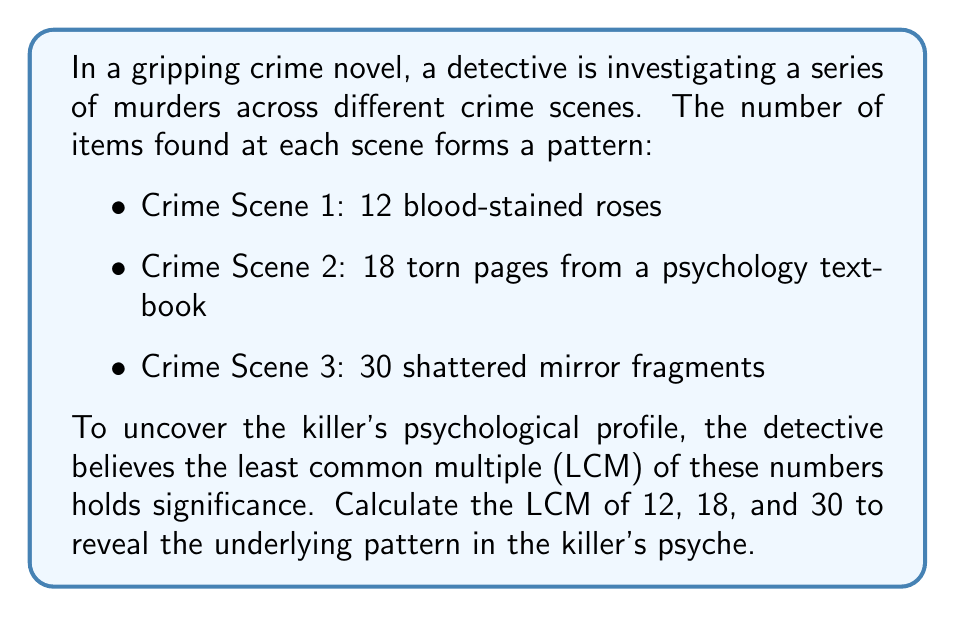What is the answer to this math problem? To find the LCM of 12, 18, and 30, we'll follow these steps:

1. First, let's find the prime factorization of each number:
   
   $12 = 2^2 \times 3$
   $18 = 2 \times 3^2$
   $30 = 2 \times 3 \times 5$

2. The LCM will include the highest power of each prime factor from any of the numbers:

   - For 2: The highest power is 2 (from 12)
   - For 3: The highest power is 2 (from 18)
   - For 5: The highest power is 1 (from 30)

3. Therefore, the LCM will be:

   $LCM = 2^2 \times 3^2 \times 5$

4. Now, let's calculate this:
   
   $LCM = 4 \times 9 \times 5 = 180$

This number, 180, represents the psychological pattern underlying the killer's actions, combining elements from all three crime scenes into a single, revealing number.
Answer: The least common multiple of 12, 18, and 30 is 180. 